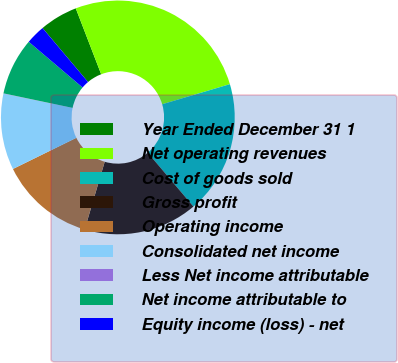Convert chart to OTSL. <chart><loc_0><loc_0><loc_500><loc_500><pie_chart><fcel>Year Ended December 31 1<fcel>Net operating revenues<fcel>Cost of goods sold<fcel>Gross profit<fcel>Operating income<fcel>Consolidated net income<fcel>Less Net income attributable<fcel>Net income attributable to<fcel>Equity income (loss) - net<nl><fcel>5.28%<fcel>26.27%<fcel>18.4%<fcel>15.77%<fcel>13.15%<fcel>10.53%<fcel>0.04%<fcel>7.9%<fcel>2.66%<nl></chart> 